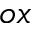<formula> <loc_0><loc_0><loc_500><loc_500>^ { o x }</formula> 